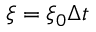Convert formula to latex. <formula><loc_0><loc_0><loc_500><loc_500>\xi = \xi _ { 0 } \Delta t</formula> 